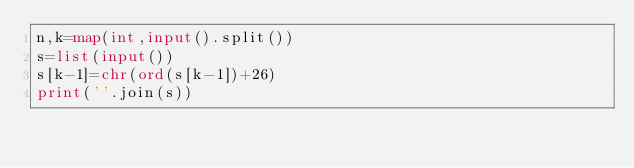<code> <loc_0><loc_0><loc_500><loc_500><_Python_>n,k=map(int,input().split())
s=list(input())
s[k-1]=chr(ord(s[k-1])+26)
print(''.join(s))</code> 